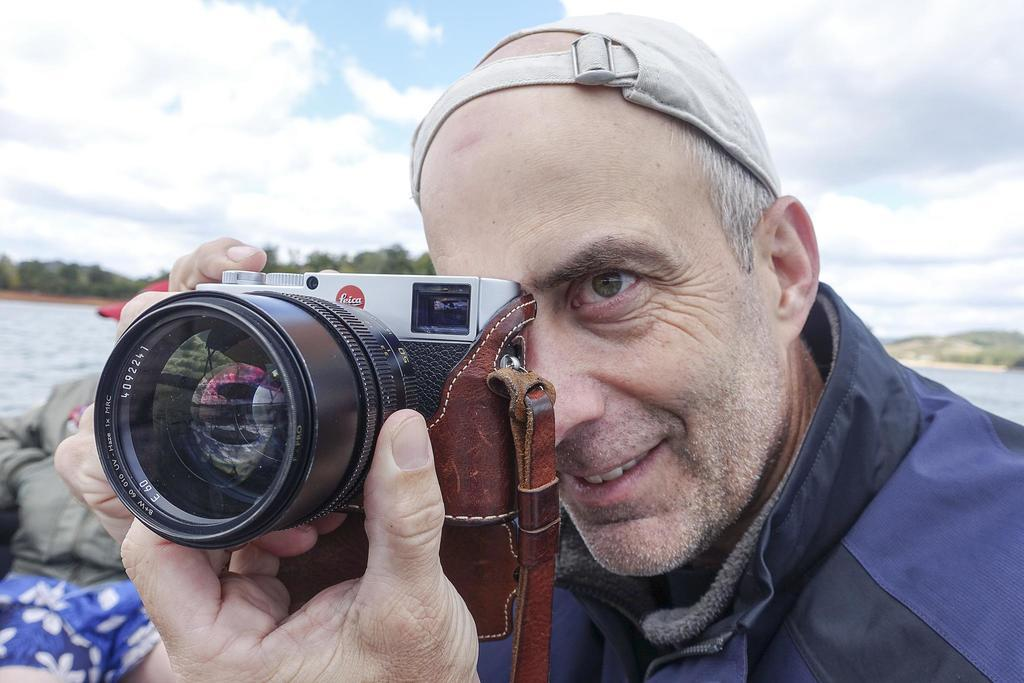What is the man in the image wearing? The man is wearing a jacket. What is the man holding in the image? The man is holding a camera. What can be seen in the distance in the image? There are trees in the distance. What body of water is present in the image? There is a freshwater river in the image. What is the condition of the sky in the image? The sky is cloudy. What is the woman in the image wearing? The woman is wearing a jacket. What type of muscle can be seen flexing in the image? There is no muscle flexing visible in the image. What kind of sponge is being used to clean the camera in the image? There is no sponge present in the image, and the camera is not being cleaned. 